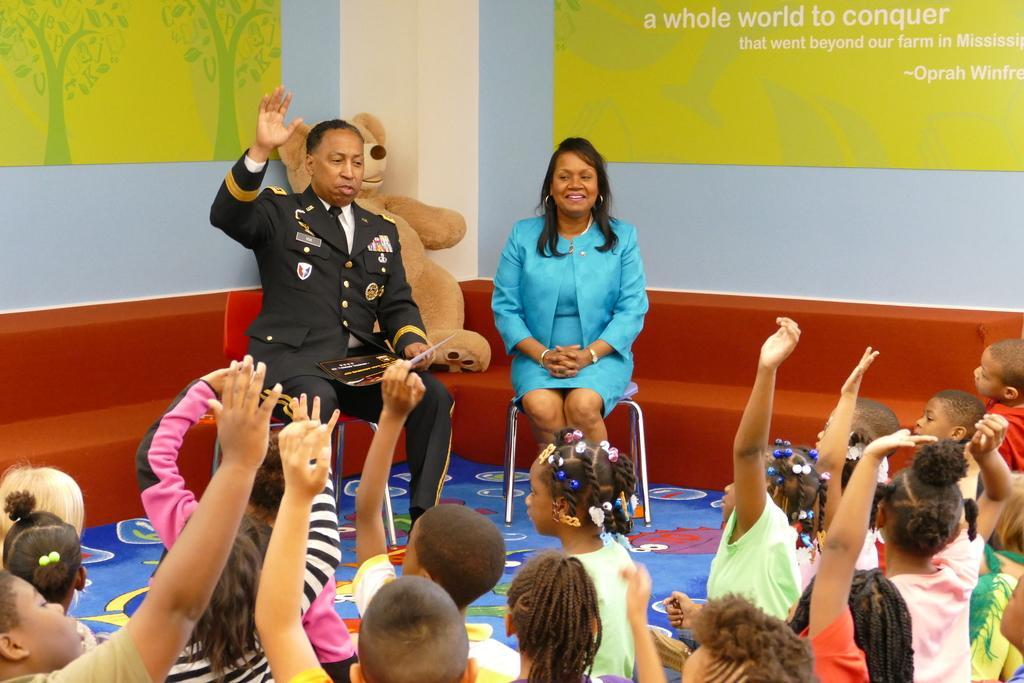How would you summarize this image in a sentence or two? Children are sitting on the floor and raising hands. 2 people are sitting on the chairs. behind them there is a brown teddy and there are green posters on the wall. 